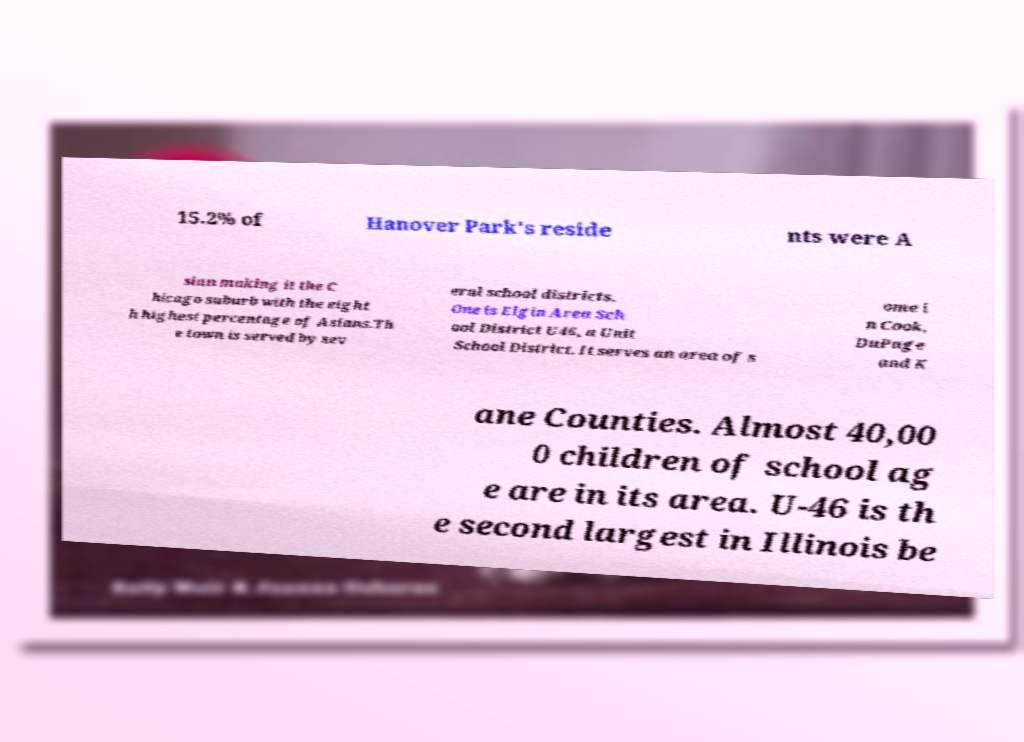Could you extract and type out the text from this image? 15.2% of Hanover Park's reside nts were A sian making it the C hicago suburb with the eight h highest percentage of Asians.Th e town is served by sev eral school districts. One is Elgin Area Sch ool District U46, a Unit School District. It serves an area of s ome i n Cook, DuPage and K ane Counties. Almost 40,00 0 children of school ag e are in its area. U-46 is th e second largest in Illinois be 